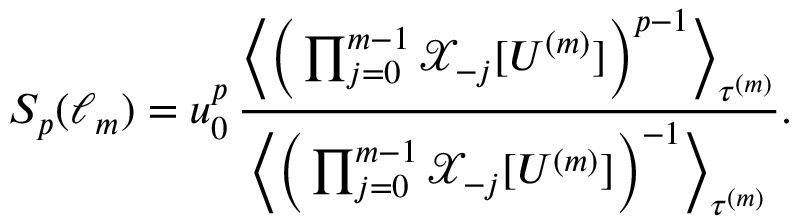<formula> <loc_0><loc_0><loc_500><loc_500>S _ { p } ( \ell _ { m } ) = u _ { 0 } ^ { p } \, \frac { \left \langle \left ( \prod _ { j = 0 } ^ { m - 1 } \mathcal { X } _ { - j } [ U ^ { ( m ) } ] \right ) ^ { p - 1 } \right \rangle _ { \tau ^ { ( m ) } } } { \left \langle \left ( \prod _ { j = 0 } ^ { m - 1 } \mathcal { X } _ { - j } [ U ^ { ( m ) } ] \right ) ^ { - 1 } \right \rangle _ { \tau ^ { ( m ) } } } .</formula> 